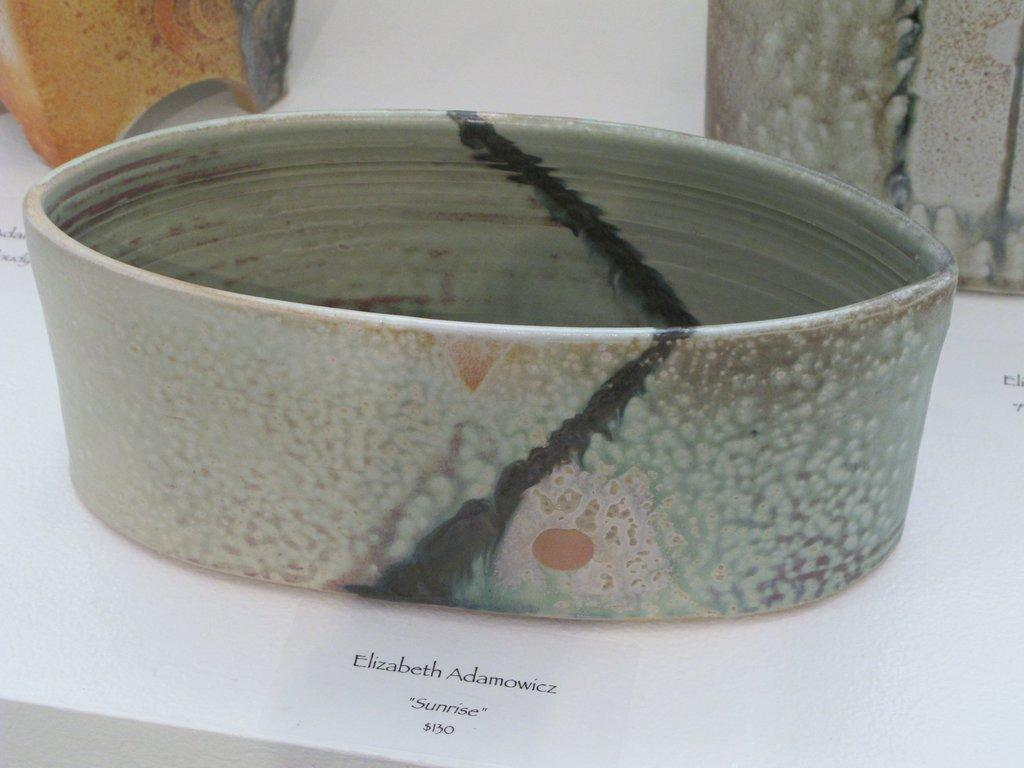What can be seen in the image? There are objects visible in the image. What is the color of the surface on which the objects are placed? There is a white surface in the image. What is written or depicted on the white surface? There is some information on the white surface. Is there a church meeting taking place at night in the image? There is no reference to a church, meeting, or nighttime setting in the image, so it is not possible to answer that question. 